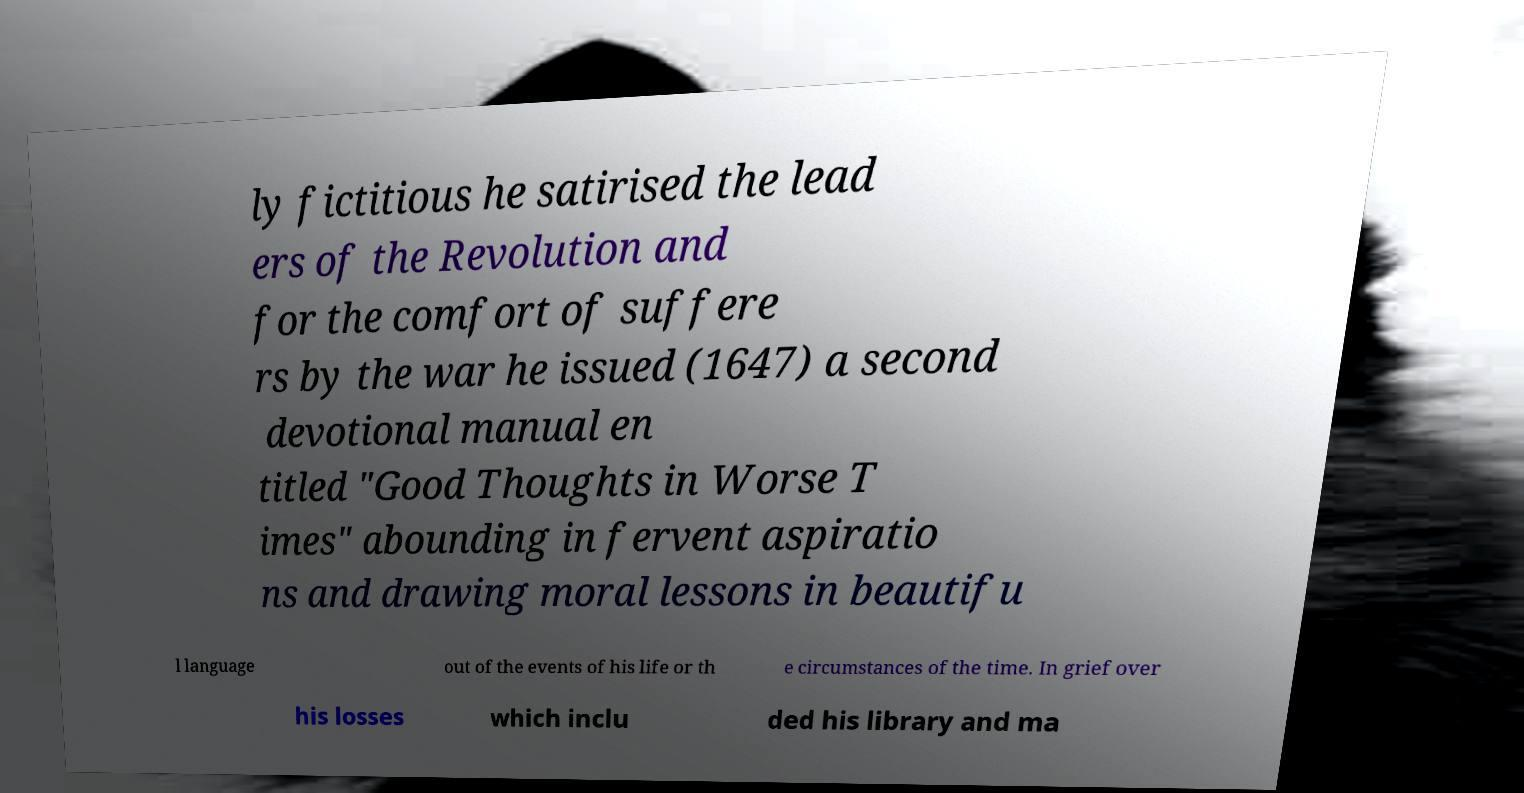What messages or text are displayed in this image? I need them in a readable, typed format. ly fictitious he satirised the lead ers of the Revolution and for the comfort of suffere rs by the war he issued (1647) a second devotional manual en titled "Good Thoughts in Worse T imes" abounding in fervent aspiratio ns and drawing moral lessons in beautifu l language out of the events of his life or th e circumstances of the time. In grief over his losses which inclu ded his library and ma 